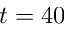<formula> <loc_0><loc_0><loc_500><loc_500>t = 4 0</formula> 